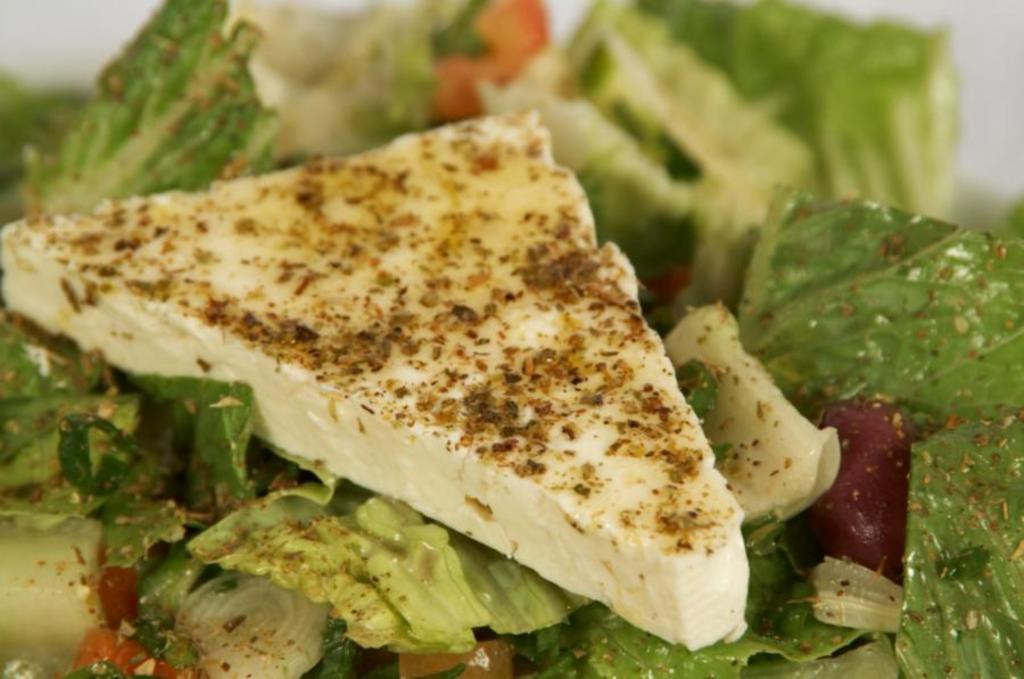What can be seen in the image related to food? There is some food visible in the image. Is there a carriage carrying a deer in the image? No, there is no carriage or deer present in the image. What type of dinner is being served in the image? The provided fact does not mention any specific type of dinner or meal; it only states that there is some food visible in the image. 